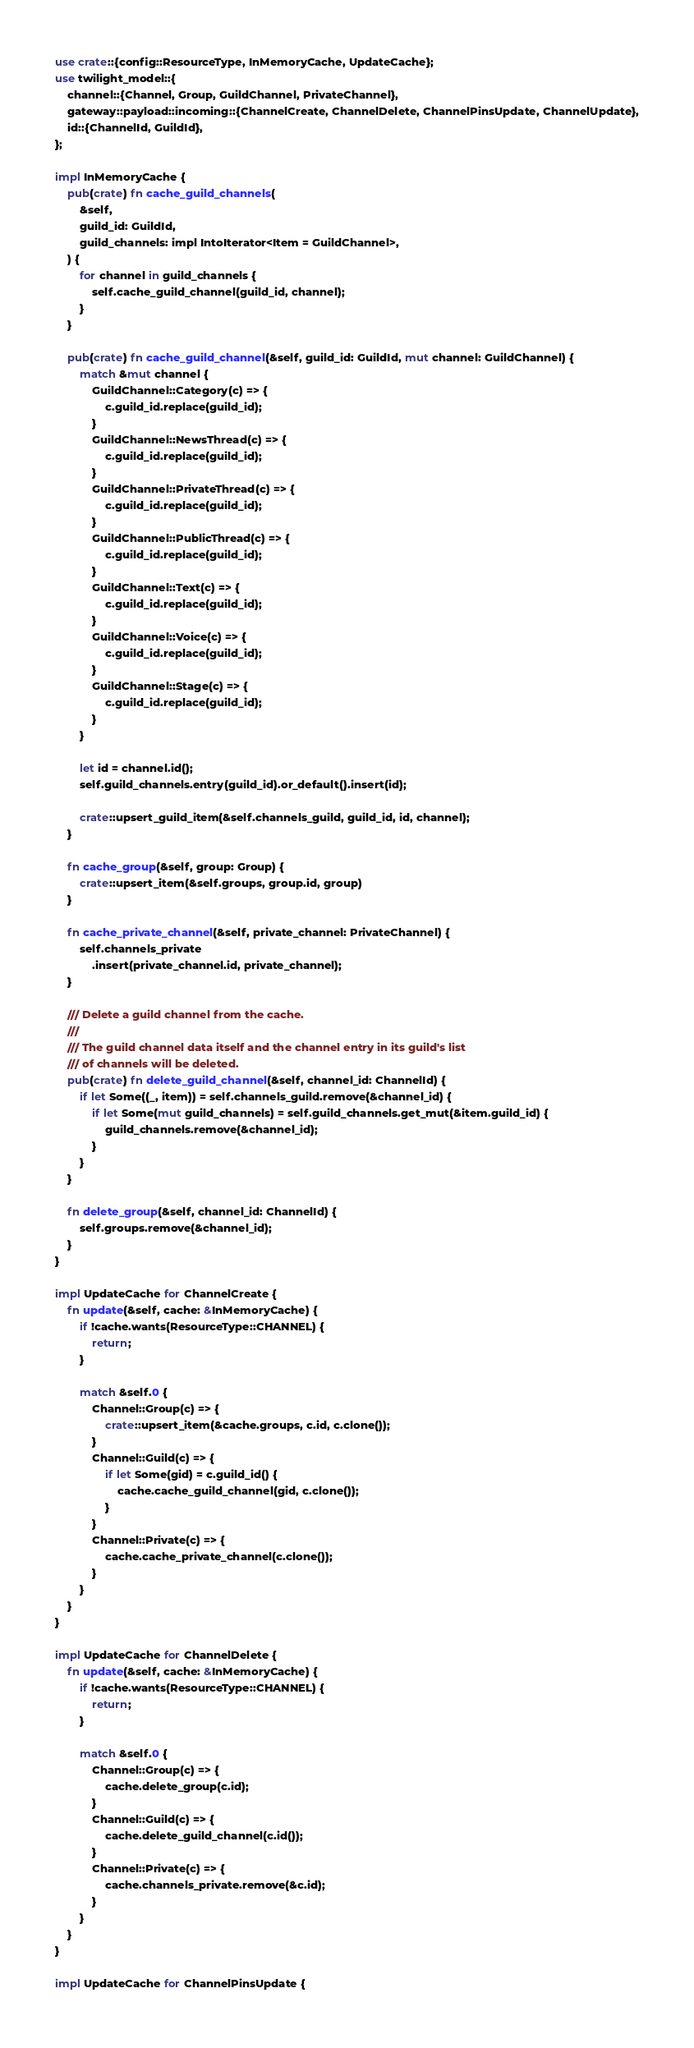<code> <loc_0><loc_0><loc_500><loc_500><_Rust_>use crate::{config::ResourceType, InMemoryCache, UpdateCache};
use twilight_model::{
    channel::{Channel, Group, GuildChannel, PrivateChannel},
    gateway::payload::incoming::{ChannelCreate, ChannelDelete, ChannelPinsUpdate, ChannelUpdate},
    id::{ChannelId, GuildId},
};

impl InMemoryCache {
    pub(crate) fn cache_guild_channels(
        &self,
        guild_id: GuildId,
        guild_channels: impl IntoIterator<Item = GuildChannel>,
    ) {
        for channel in guild_channels {
            self.cache_guild_channel(guild_id, channel);
        }
    }

    pub(crate) fn cache_guild_channel(&self, guild_id: GuildId, mut channel: GuildChannel) {
        match &mut channel {
            GuildChannel::Category(c) => {
                c.guild_id.replace(guild_id);
            }
            GuildChannel::NewsThread(c) => {
                c.guild_id.replace(guild_id);
            }
            GuildChannel::PrivateThread(c) => {
                c.guild_id.replace(guild_id);
            }
            GuildChannel::PublicThread(c) => {
                c.guild_id.replace(guild_id);
            }
            GuildChannel::Text(c) => {
                c.guild_id.replace(guild_id);
            }
            GuildChannel::Voice(c) => {
                c.guild_id.replace(guild_id);
            }
            GuildChannel::Stage(c) => {
                c.guild_id.replace(guild_id);
            }
        }

        let id = channel.id();
        self.guild_channels.entry(guild_id).or_default().insert(id);

        crate::upsert_guild_item(&self.channels_guild, guild_id, id, channel);
    }

    fn cache_group(&self, group: Group) {
        crate::upsert_item(&self.groups, group.id, group)
    }

    fn cache_private_channel(&self, private_channel: PrivateChannel) {
        self.channels_private
            .insert(private_channel.id, private_channel);
    }

    /// Delete a guild channel from the cache.
    ///
    /// The guild channel data itself and the channel entry in its guild's list
    /// of channels will be deleted.
    pub(crate) fn delete_guild_channel(&self, channel_id: ChannelId) {
        if let Some((_, item)) = self.channels_guild.remove(&channel_id) {
            if let Some(mut guild_channels) = self.guild_channels.get_mut(&item.guild_id) {
                guild_channels.remove(&channel_id);
            }
        }
    }

    fn delete_group(&self, channel_id: ChannelId) {
        self.groups.remove(&channel_id);
    }
}

impl UpdateCache for ChannelCreate {
    fn update(&self, cache: &InMemoryCache) {
        if !cache.wants(ResourceType::CHANNEL) {
            return;
        }

        match &self.0 {
            Channel::Group(c) => {
                crate::upsert_item(&cache.groups, c.id, c.clone());
            }
            Channel::Guild(c) => {
                if let Some(gid) = c.guild_id() {
                    cache.cache_guild_channel(gid, c.clone());
                }
            }
            Channel::Private(c) => {
                cache.cache_private_channel(c.clone());
            }
        }
    }
}

impl UpdateCache for ChannelDelete {
    fn update(&self, cache: &InMemoryCache) {
        if !cache.wants(ResourceType::CHANNEL) {
            return;
        }

        match &self.0 {
            Channel::Group(c) => {
                cache.delete_group(c.id);
            }
            Channel::Guild(c) => {
                cache.delete_guild_channel(c.id());
            }
            Channel::Private(c) => {
                cache.channels_private.remove(&c.id);
            }
        }
    }
}

impl UpdateCache for ChannelPinsUpdate {</code> 